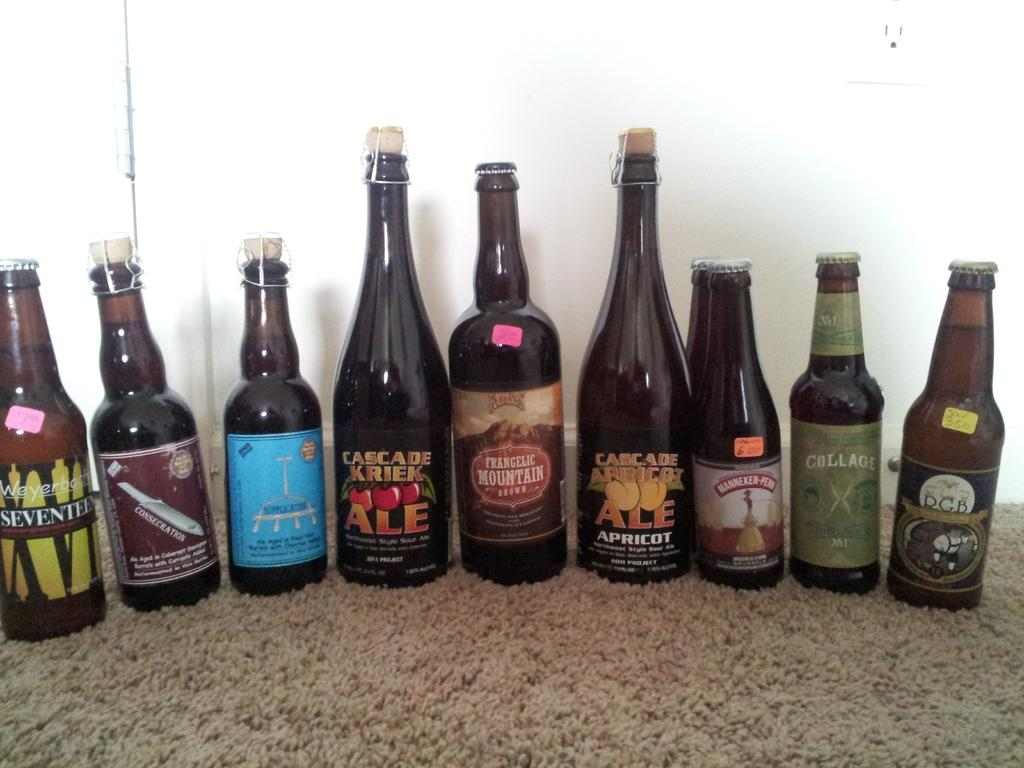<image>
Provide a brief description of the given image. the word mountain is on the front of a bottle 